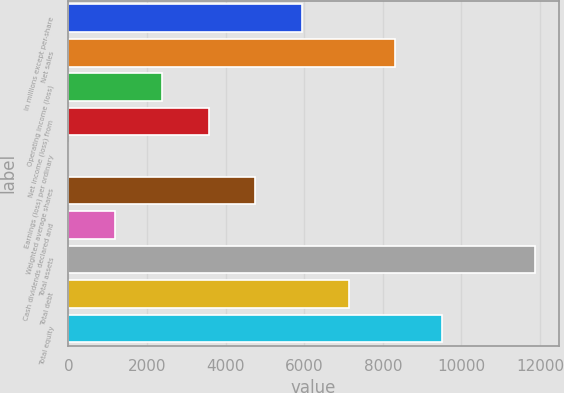Convert chart to OTSL. <chart><loc_0><loc_0><loc_500><loc_500><bar_chart><fcel>In millions except per-share<fcel>Net sales<fcel>Operating income (loss)<fcel>Net income (loss) from<fcel>Earnings (loss) per ordinary<fcel>Weighted average shares<fcel>Cash dividends declared and<fcel>Total assets<fcel>Total debt<fcel>Total equity<nl><fcel>5941.69<fcel>8318.11<fcel>2377.06<fcel>3565.27<fcel>0.64<fcel>4753.48<fcel>1188.85<fcel>11882.7<fcel>7129.9<fcel>9506.32<nl></chart> 